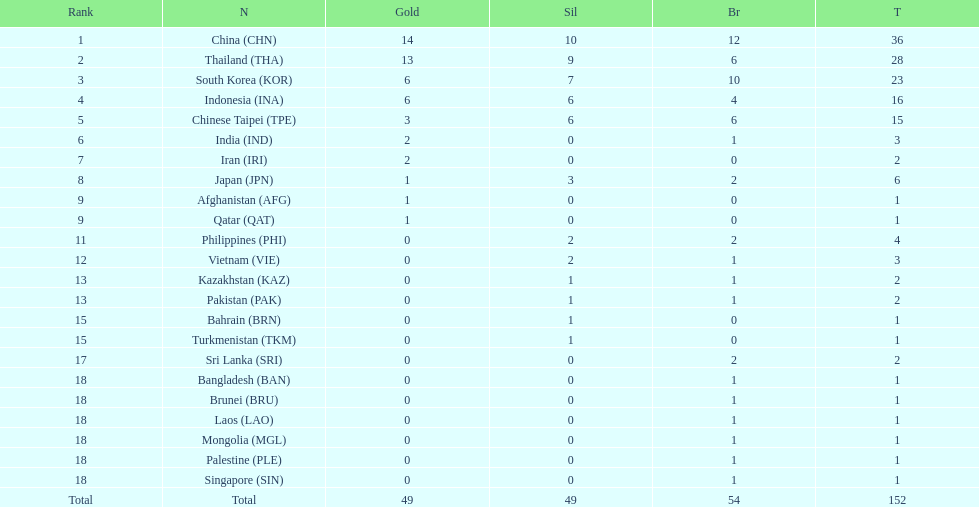How many combined silver medals did china, india, and japan earn ? 13. 